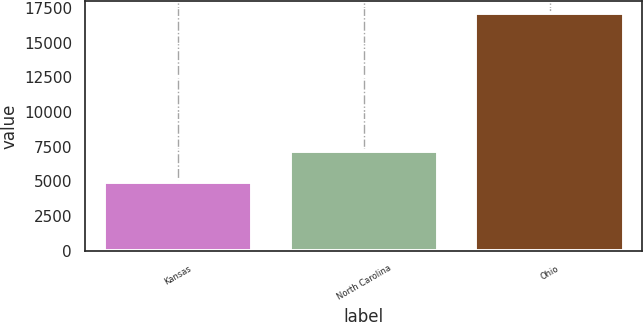Convert chart. <chart><loc_0><loc_0><loc_500><loc_500><bar_chart><fcel>Kansas<fcel>North Carolina<fcel>Ohio<nl><fcel>4961<fcel>7203<fcel>17134<nl></chart> 